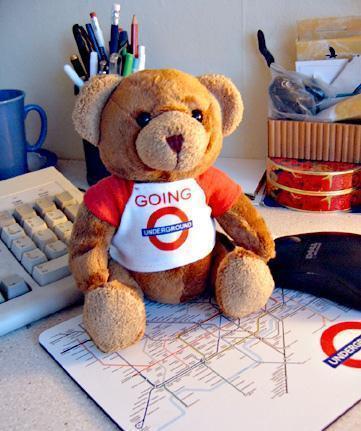What color is the big circular ring in the logo of the bear's t-shirt?
From the following set of four choices, select the accurate answer to respond to the question.
Options: Blue, yellow, red, pink. Red. 